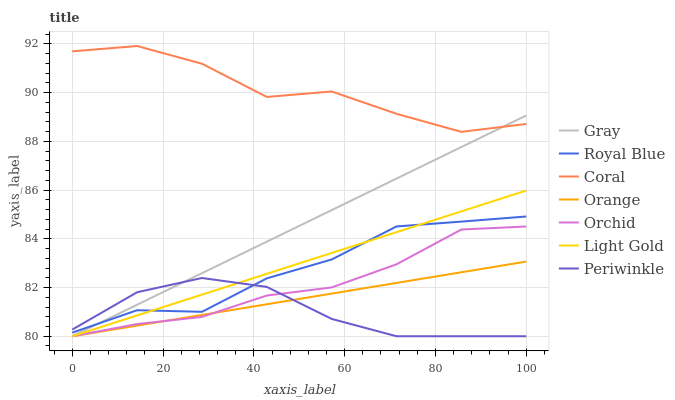Does Royal Blue have the minimum area under the curve?
Answer yes or no. No. Does Royal Blue have the maximum area under the curve?
Answer yes or no. No. Is Royal Blue the smoothest?
Answer yes or no. No. Is Royal Blue the roughest?
Answer yes or no. No. Does Royal Blue have the lowest value?
Answer yes or no. No. Does Royal Blue have the highest value?
Answer yes or no. No. Is Periwinkle less than Coral?
Answer yes or no. Yes. Is Coral greater than Periwinkle?
Answer yes or no. Yes. Does Periwinkle intersect Coral?
Answer yes or no. No. 